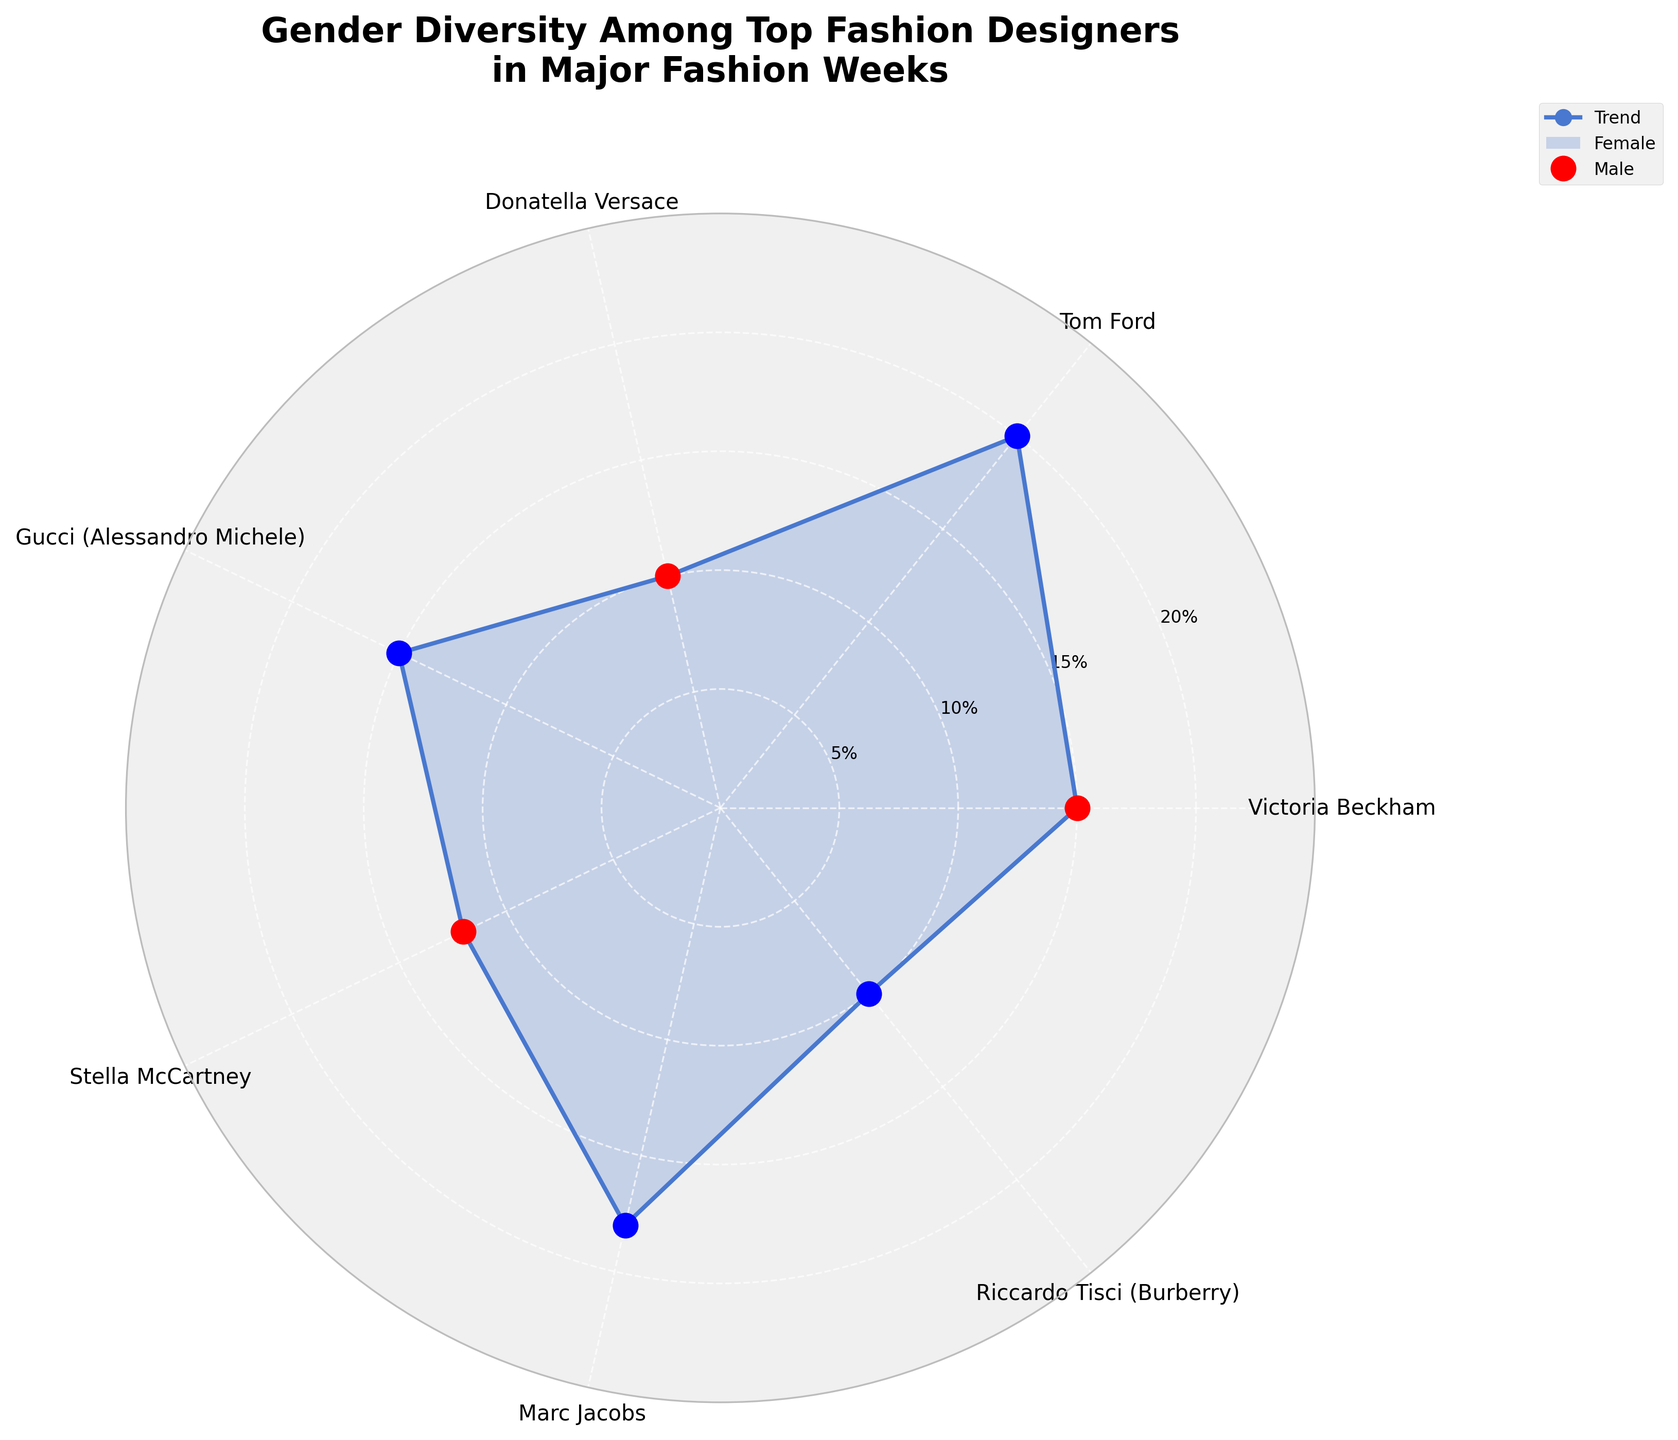what is the title of the plot? The title of the plot is shown at the top of the figure in bold text.
Answer: Gender Diversity Among Top Fashion Designers in Major Fashion Weeks How many fashion designers are featured in the plot? Count the number of angular ticks or labels around the plot.
Answer: Seven designers Which designer has the highest percentage in any Fashion Week? Look for the largest data point ('o') on the plot, which will indicate the highest value.
Answer: Tom Ford What is the combined percentage representation of female designers across all Fashion Weeks? Add up the percentages of female designers: Victoria Beckham (15) + Donatella Versace (10) + Stella McCartney (12).
Answer: 37% Is the percentage representation of male designers in New York Fashion Week higher than 35%? Add percentages for male designers in New York Fashion Week: Tom Ford (20) + Marc Jacobs (18) = 38. Compare this sum to 35.
Answer: Yes Which male designer has the lowest percentage representation in any Fashion Week? Look for the smallest data point ('o') marked in blue, then identify the corresponding designer from the labels.
Answer: Riccardo Tisci (10%) By how many percentage points does Tom Ford's representation surpass Victoria Beckham's? Subtract Victoria Beckham's percentage (15) from Tom Ford's percentage (20).
Answer: 5 percentage points What is the difference in percentage representation between Gucci and Donatella Versace in Milan Fashion Week? Subtract Donatella Versace's percentage (10) from Gucci's percentage (15).
Answer: 5 percentage points How many Fashion Weeks have a greater representation of male designers compared to female designers? Count the fashion weeks where the sum of the male designers' percentages exceeds that of the female designers. New York: 38 vs 0, London: 10 vs 15, Paris: Stella McCartney (only one female designer here), Milan: 15 (Gucci) vs 10 (Donatella).
Answer: Three Fashion Weeks 